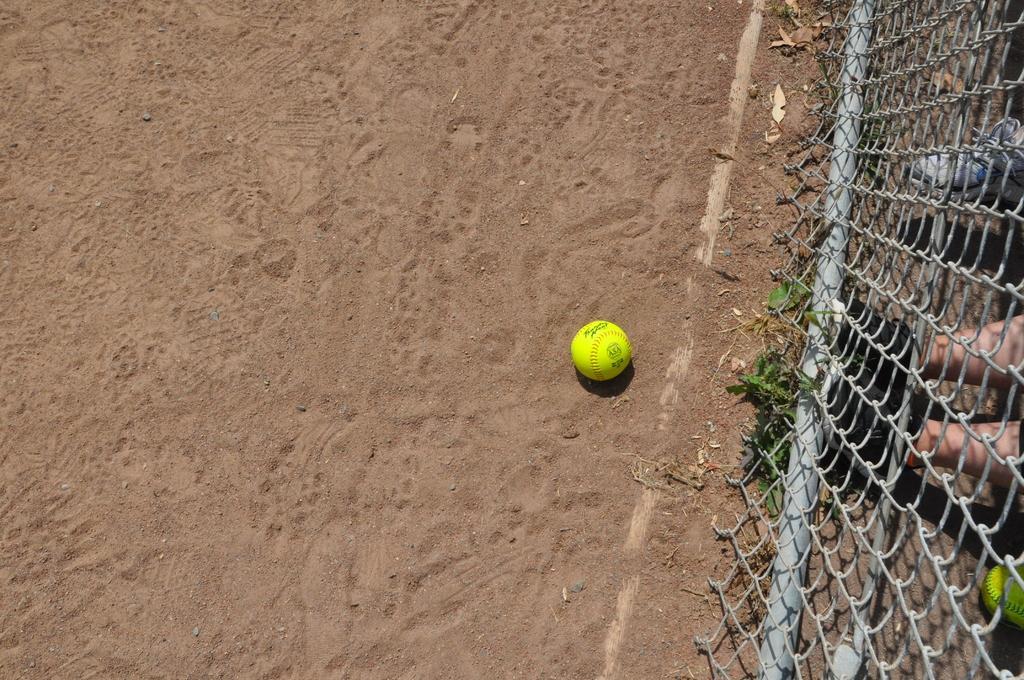Please provide a concise description of this image. In this picture we can see ball on the ground and mesh and leaves, through this mesh we can see person's legs with footwear and we can see shoe and ball. 